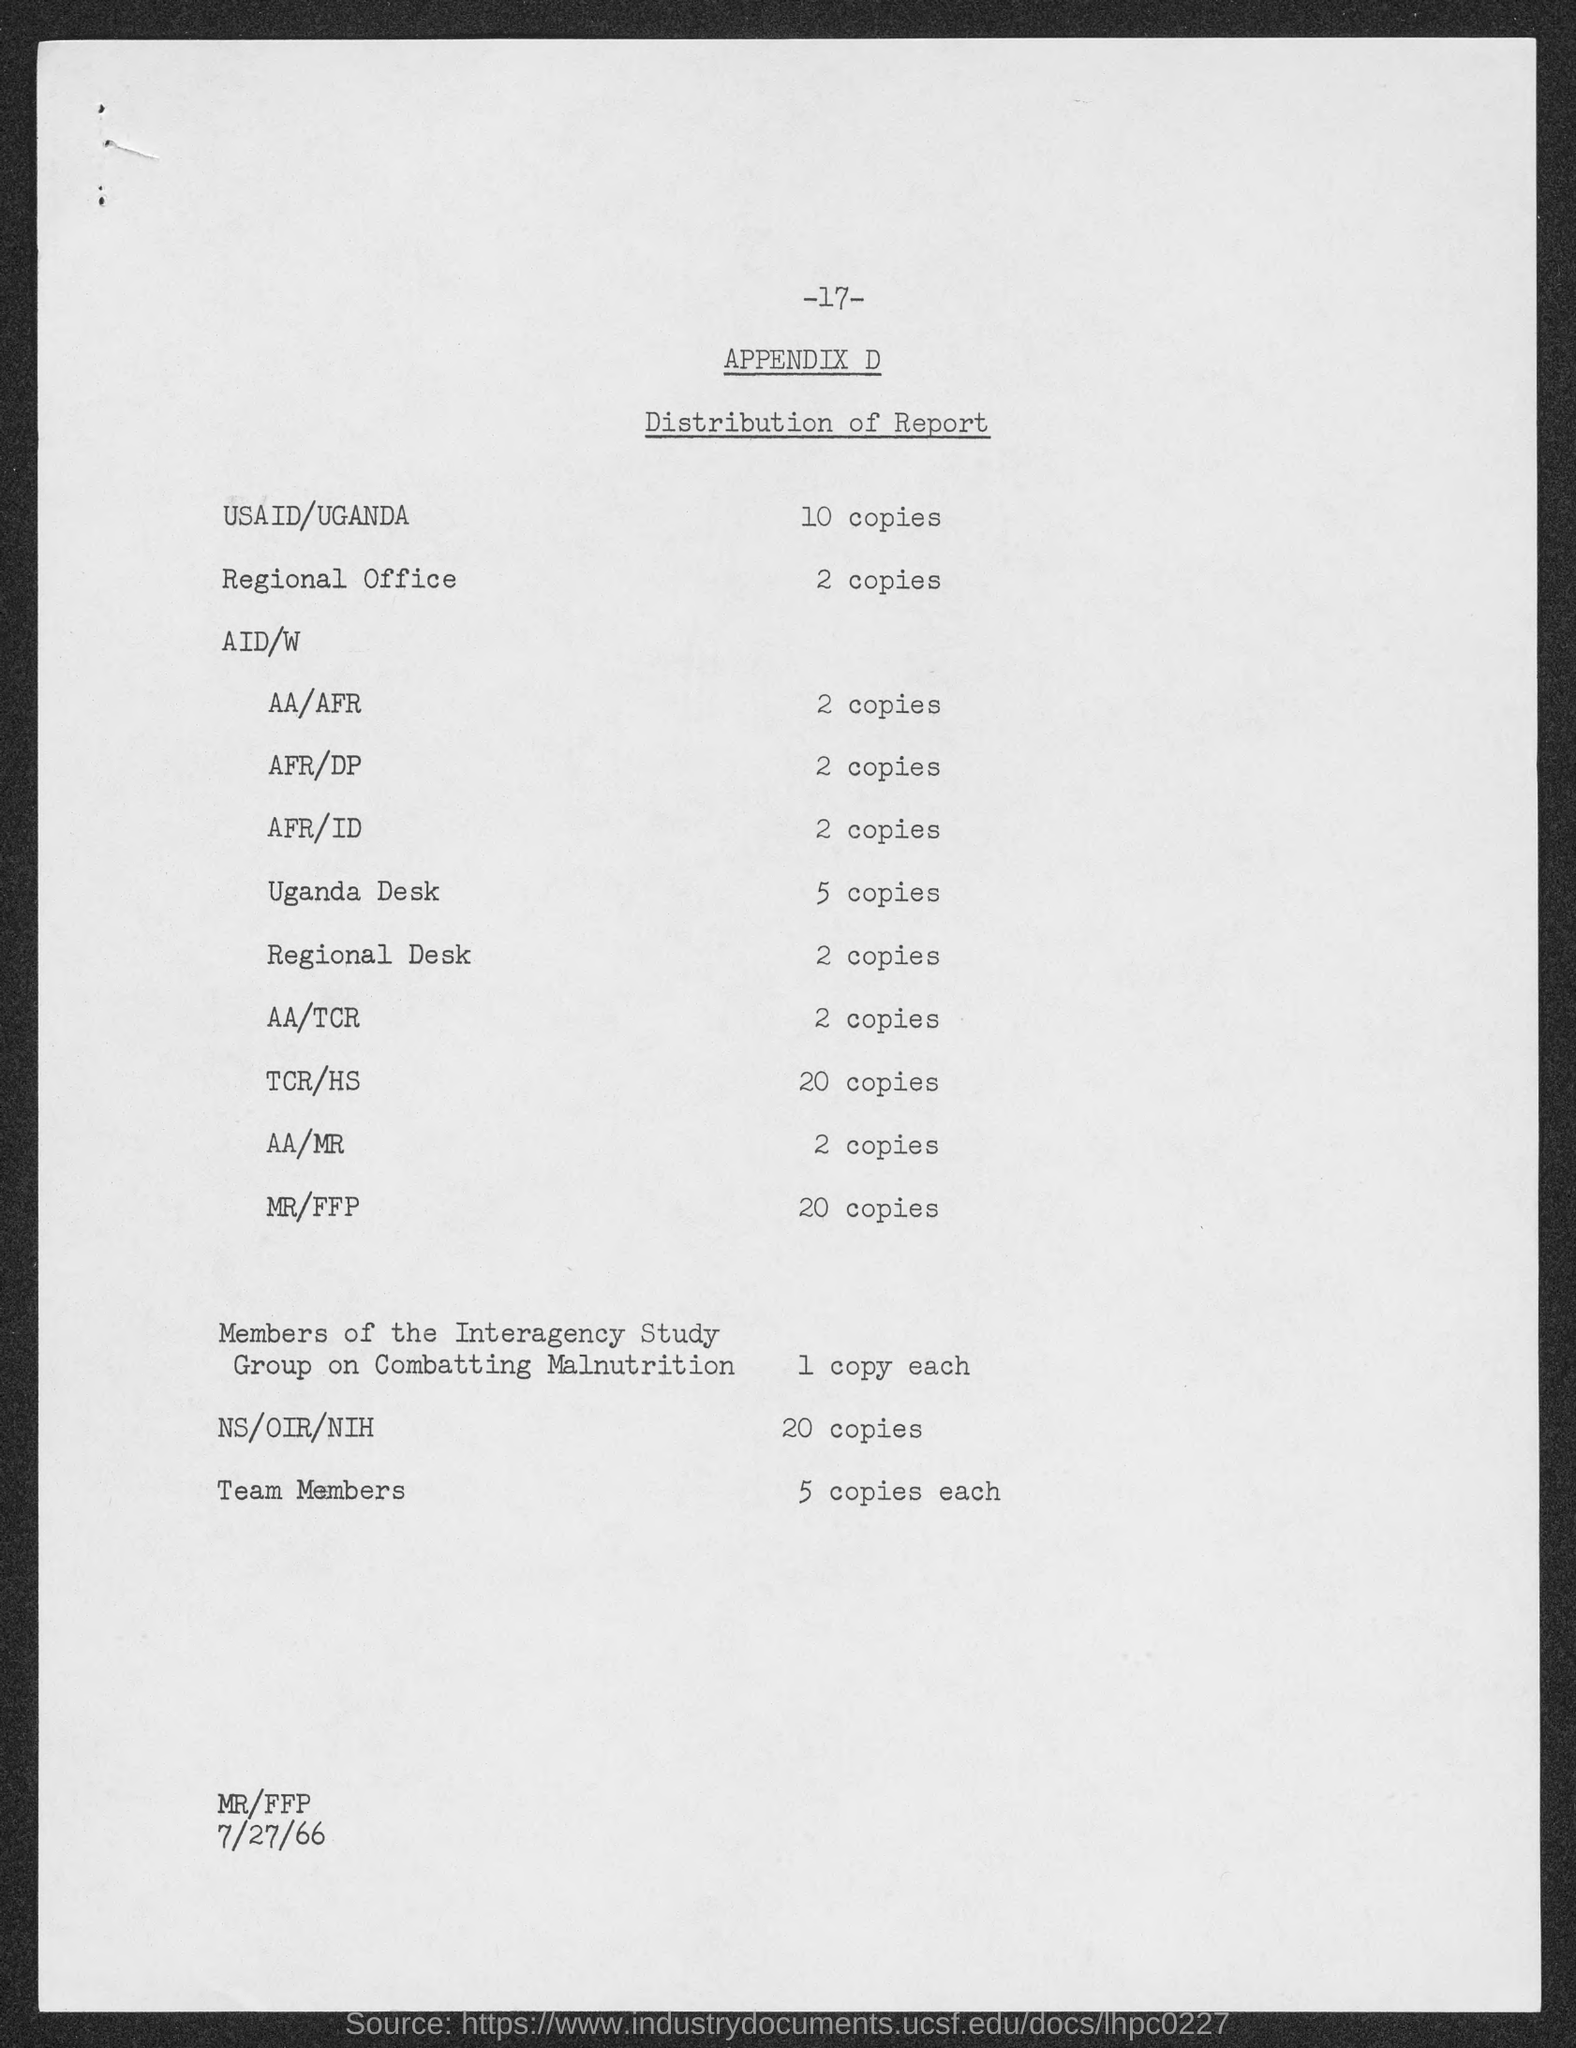Point out several critical features in this image. The number of copies distributed in the regional desk is 2. The report is distributed in MR/FFP in 20 copies. Five copies of the publication have been distributed in the Uganda Desk. Two copies of the report are distributed in the regional office. The exact number of copies distributed to NS, OIR, and NIH has not been specified. 